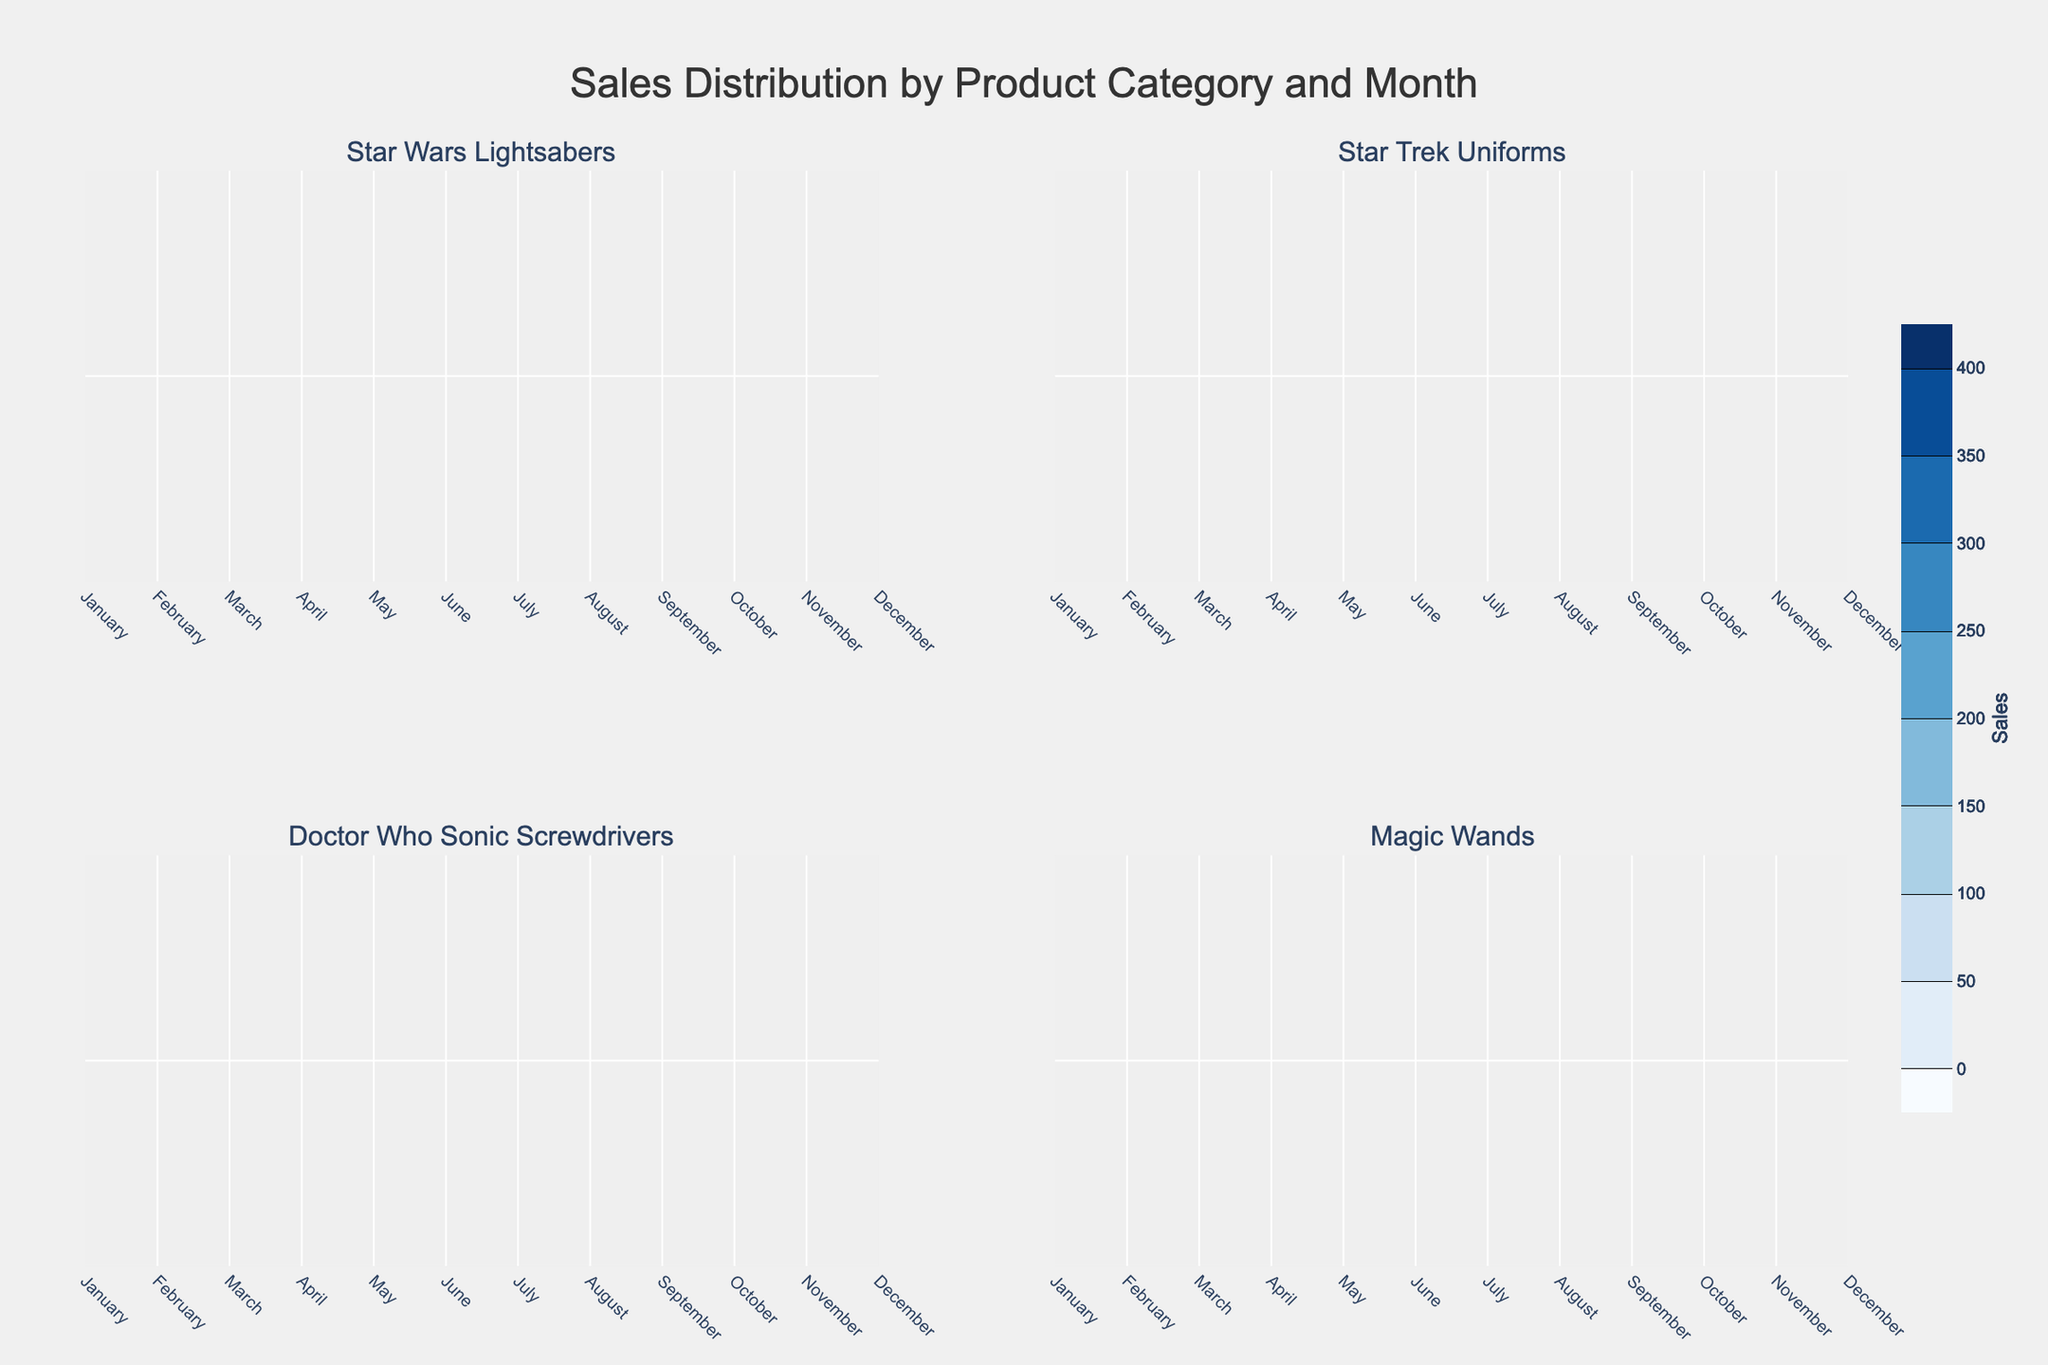What's the title of the plot? The title is usually placed at the top of the figure, and it provides an overview of what the figure represents. Here, it’s "Sales Distribution by Product Category and Month".
Answer: Sales Distribution by Product Category and Month Which month shows the highest sales for Star Wars Lightsabers? By examining the plot for Star Wars Lightsabers, look for the contour with the highest sales value which peaks in December.
Answer: December Among all categories, which month has the lowest sales value? Review each subplot to find the lowest contour value. The January subplot for Magic Wands has the lowest sales value of 40.
Answer: January When comparing Star Trek Uniforms and Doctor Who Sonic Screwdrivers in April, which category sold more? Check both subplots in April. Contour lines in Star Trek Uniforms reach higher sales values (110) compared to Doctor Who Sonic Screwdrivers (85).
Answer: Star Trek Uniforms Which months have a sales peak for both Star Wars Lightsabers and Magic Wands? Identify months in both subplots where contours reach their highest values. Both have peaks in December.
Answer: December What's the overall trend of sales for Star Wars Lightsabers throughout the year? Analyze the contour plot for Star Wars Lightsabers to identify if sales generally increase, decrease, or remain stable, noting that sales increase steadily from January to December.
Answer: Increasing trend How does the sales distribution in May compare between Doctor Who Sonic Screwdrivers and Magic Wands? Compare the contours in both subplots for May. Doctor Who Sonic Screwdrivers have higher sales (90) than Magic Wands (70).
Answer: Doctor Who Sonic Screwdrivers What is the maximum sales value for Star Trek Uniforms and in which month does it occur? Inspect the highest point in the contour plot for Star Trek Uniforms, which is in December with a value of 180.
Answer: 180 in December Which product category has the most significant fluctuation in sales throughout the year? Compare the contour plots of all categories. Star Wars Lightsabers show the largest range from 120 in January to 400 in December.
Answer: Star Wars Lightsabers 